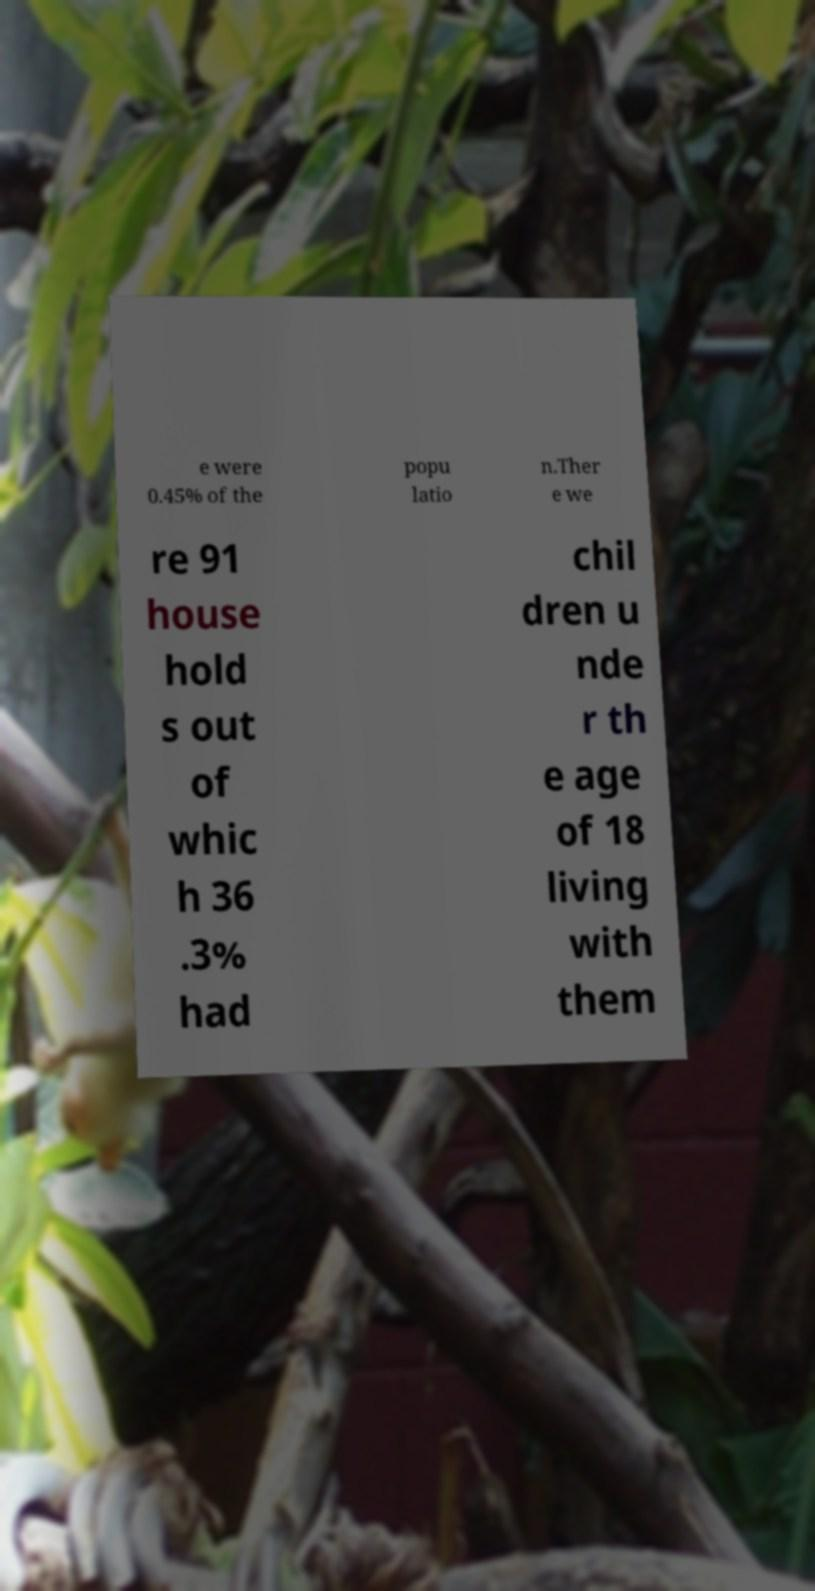I need the written content from this picture converted into text. Can you do that? e were 0.45% of the popu latio n.Ther e we re 91 house hold s out of whic h 36 .3% had chil dren u nde r th e age of 18 living with them 